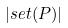<formula> <loc_0><loc_0><loc_500><loc_500>| s e t ( P ) |</formula> 